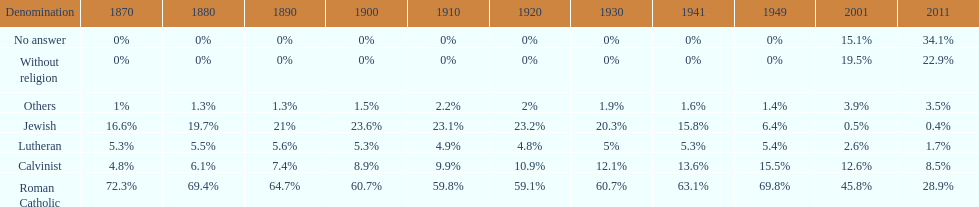How many denominations never dropped below 20%? 1. Can you parse all the data within this table? {'header': ['Denomination', '1870', '1880', '1890', '1900', '1910', '1920', '1930', '1941', '1949', '2001', '2011'], 'rows': [['No answer', '0%', '0%', '0%', '0%', '0%', '0%', '0%', '0%', '0%', '15.1%', '34.1%'], ['Without religion', '0%', '0%', '0%', '0%', '0%', '0%', '0%', '0%', '0%', '19.5%', '22.9%'], ['Others', '1%', '1.3%', '1.3%', '1.5%', '2.2%', '2%', '1.9%', '1.6%', '1.4%', '3.9%', '3.5%'], ['Jewish', '16.6%', '19.7%', '21%', '23.6%', '23.1%', '23.2%', '20.3%', '15.8%', '6.4%', '0.5%', '0.4%'], ['Lutheran', '5.3%', '5.5%', '5.6%', '5.3%', '4.9%', '4.8%', '5%', '5.3%', '5.4%', '2.6%', '1.7%'], ['Calvinist', '4.8%', '6.1%', '7.4%', '8.9%', '9.9%', '10.9%', '12.1%', '13.6%', '15.5%', '12.6%', '8.5%'], ['Roman Catholic', '72.3%', '69.4%', '64.7%', '60.7%', '59.8%', '59.1%', '60.7%', '63.1%', '69.8%', '45.8%', '28.9%']]} 